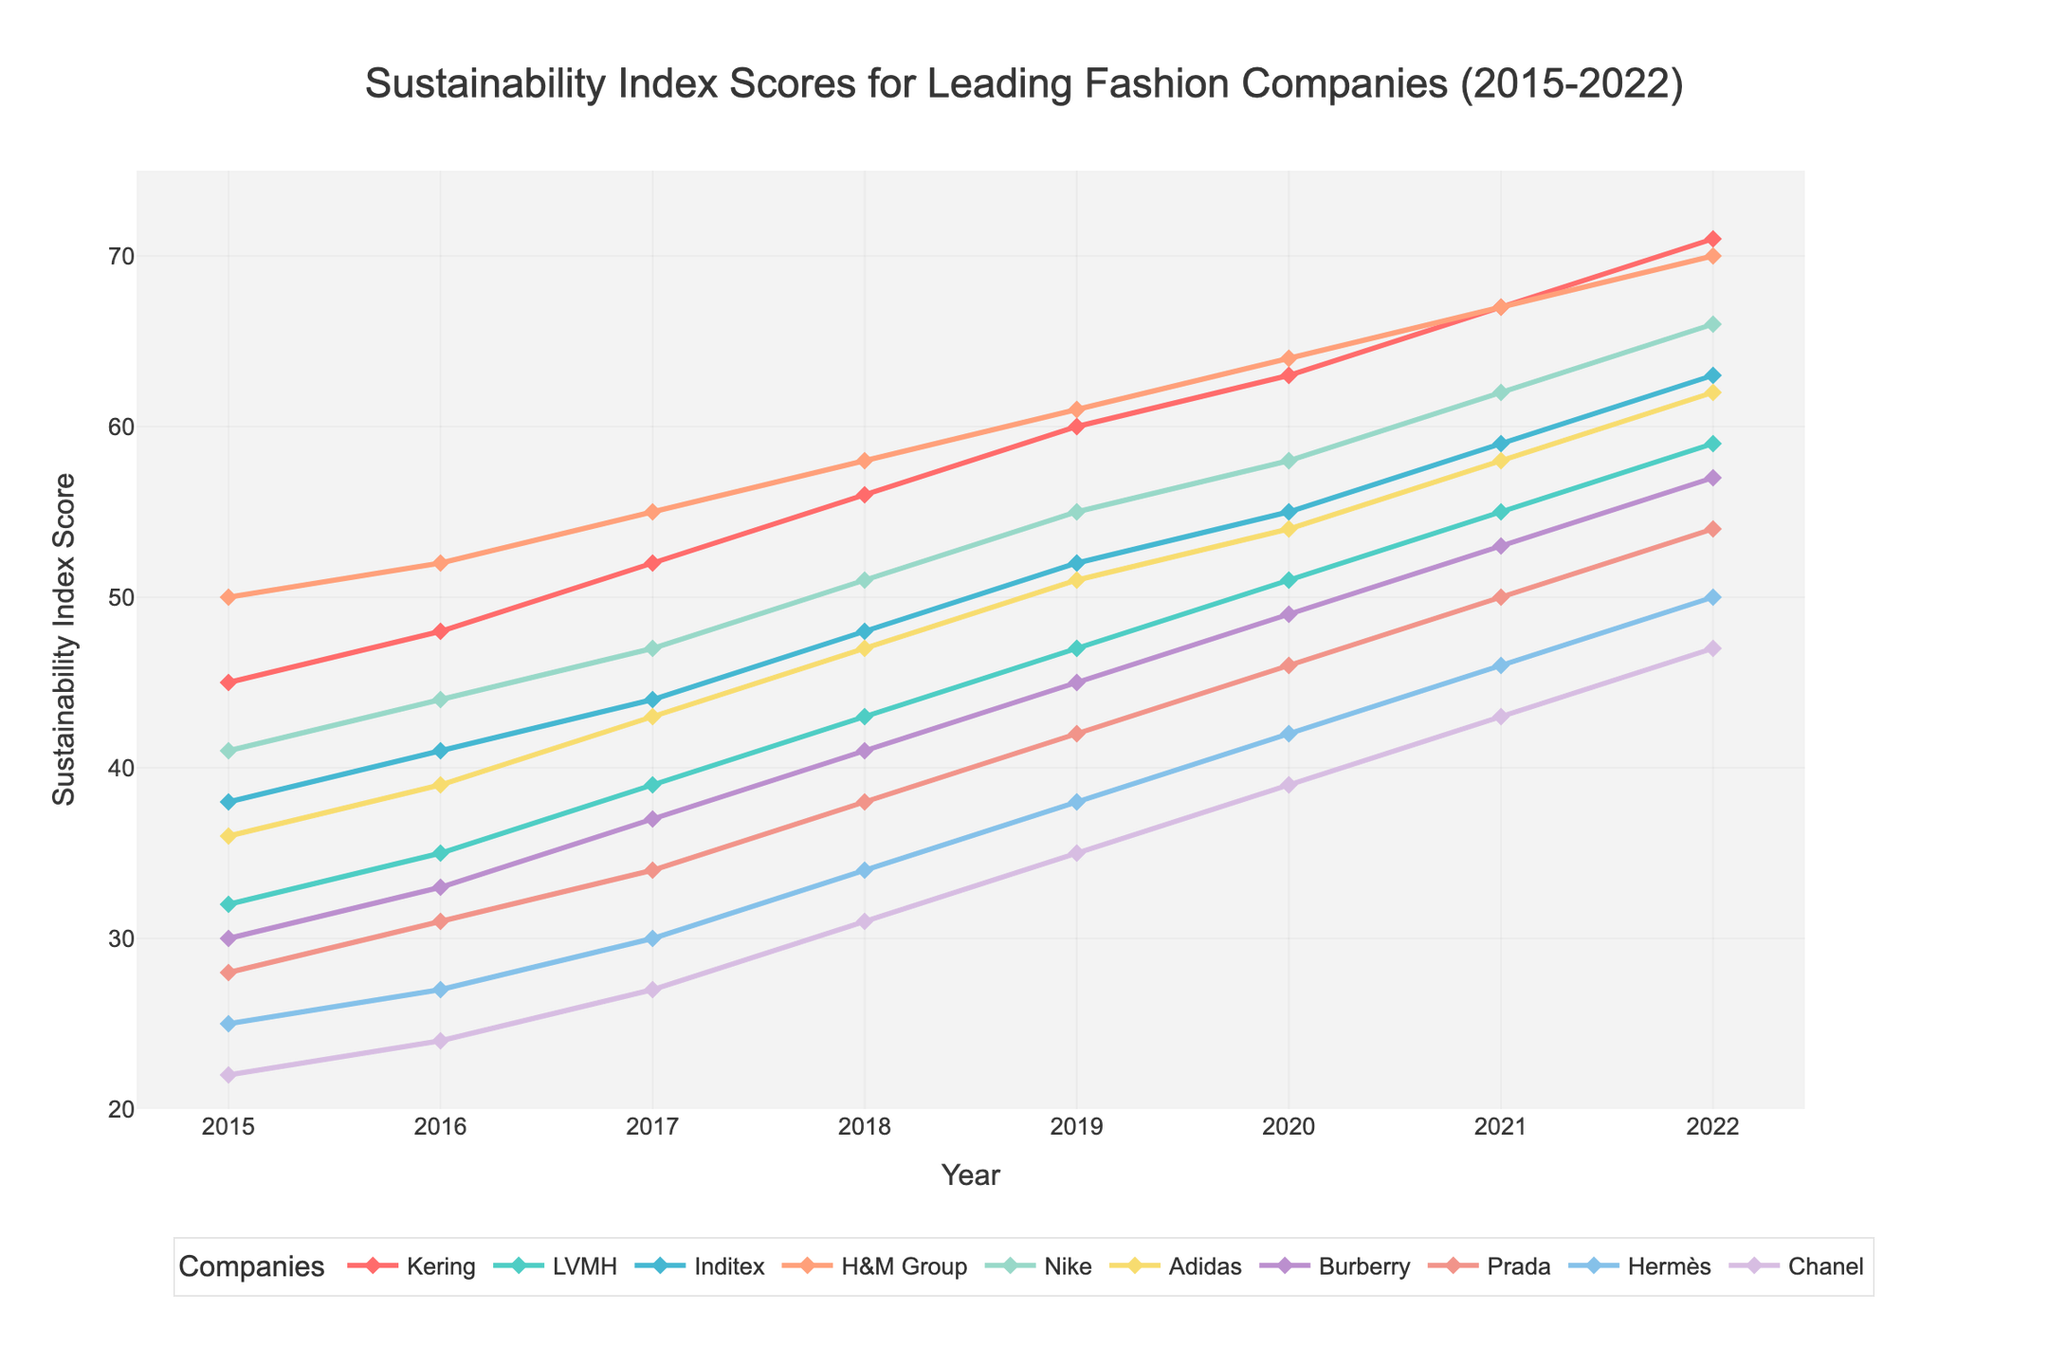what is the highest sustainability index score achieved by any company? By examining the graph and locating the peak points for each company's line, the highest score is at the endpoint of Kering's line in 2022.
Answer: 71 which company showed the most consistent increase in sustainability scores from 2015 to 2022? By visually checking the smoothness and uniformity of the upward trends among the lines, Kering's trend is consistently upward without major fluctuations.
Answer: Kering which two companies have the closest sustainability index scores in 2022? By comparing the endpoints of all the lines in 2022, Prada and Burberry have close scores of 54 and 57 respectively.
Answer: Burberry, Prada what is the total change in sustainability score for Adidas from 2015 to 2022? The score for Adidas in 2022 is 62, and in 2015 it was 36. The total change is calculated by subtracting the 2015 score from the 2022 score. 62 - 36 = 26
Answer: 26 which company had the largest jump in sustainability score between two consecutive years, and in which years did it occur? By visually inspecting the graph for the steepest slope in any of the lines, in 2018-2019, Adidas had the largest jump from 47 to 51, a change of 4 points.
Answer: Adidas, 2018-2019 how does the median sustainability score of Kering compare to Hermès in 2022? The score for Kering in 2022 is 71, and for Hermès, it is 50. The median simply represents the middle value of the score range of each company as a single point on a comparative basis.
Answer: Kering has a higher score than Hermès between which years did Kering first surpass a score of 60? By inspecting Kering's line, Kering surpasses 60 between 2018 and 2019.
Answer: 2018 and 2019 in 2020, how many companies had sustainability index scores above 50? By examining the bars at the 2020 mark, the companies Kering, LVMH, Inditex, H&M Group, Nike, Adidas, Burberry, and Prada all have scores above 50. The total count is 8.
Answer: 8 